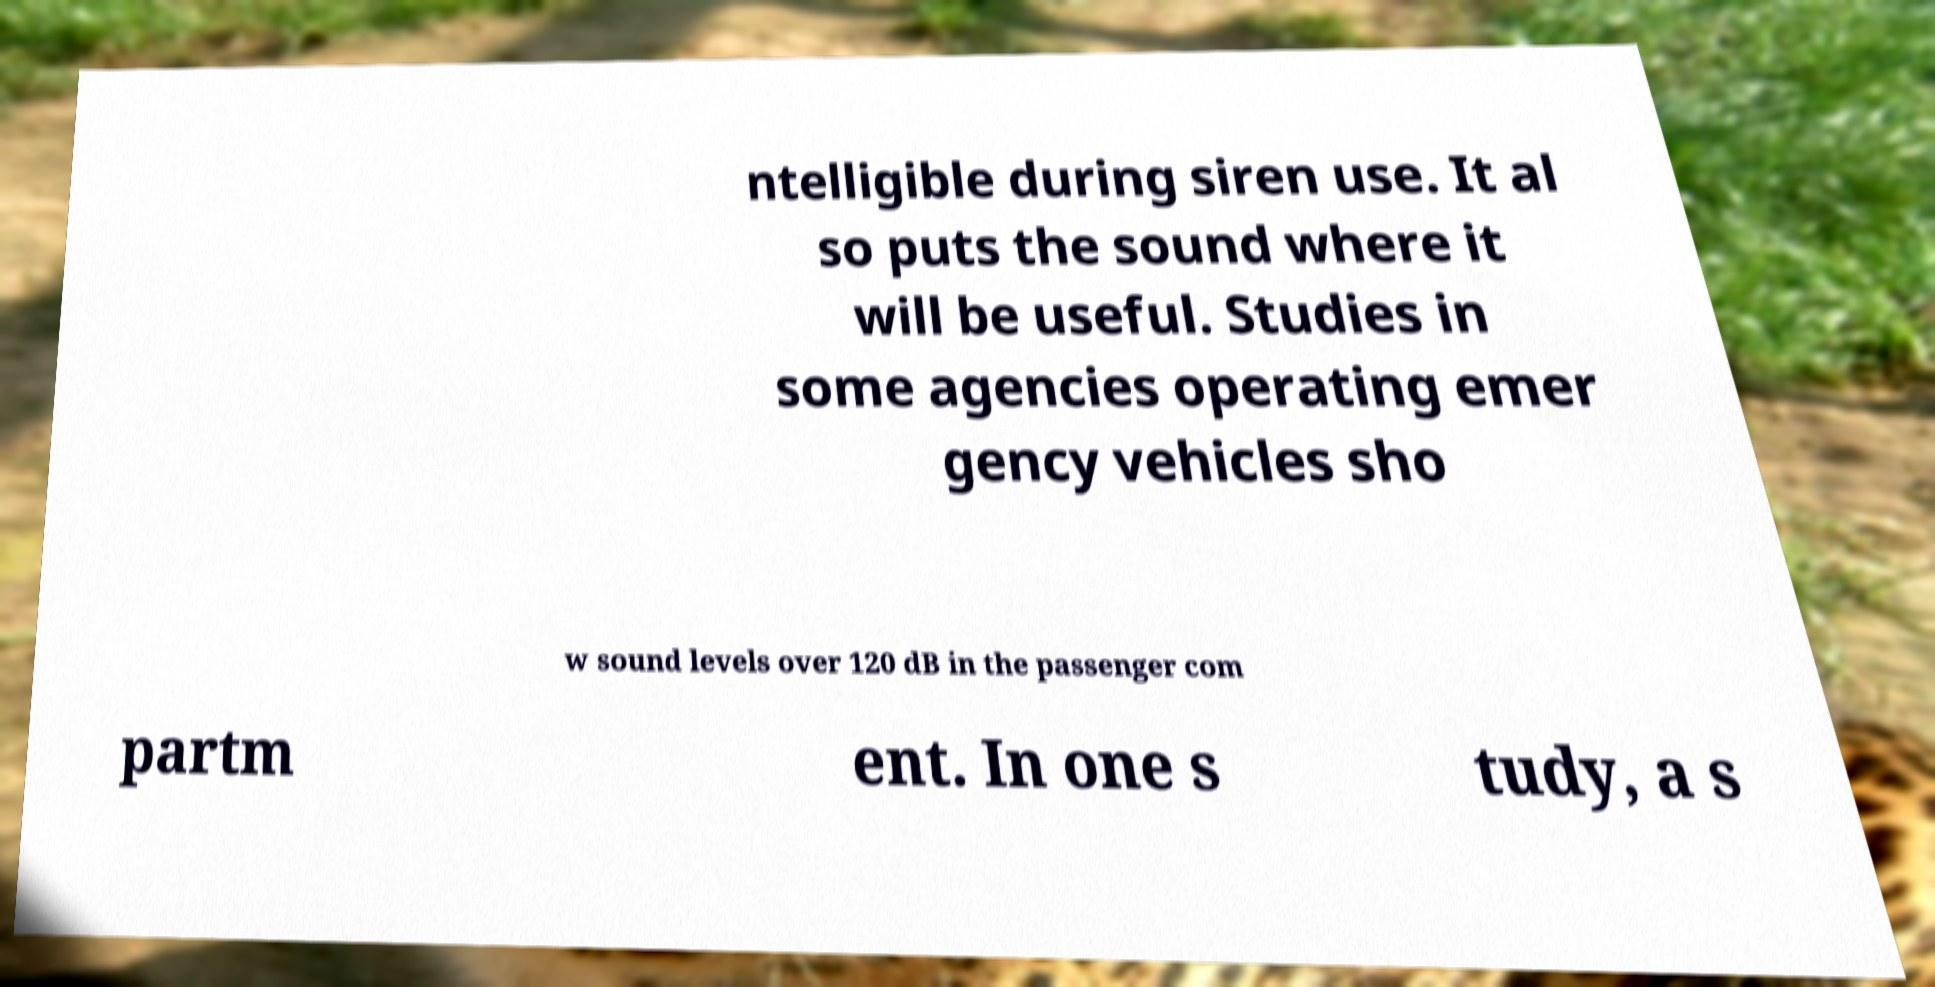Could you extract and type out the text from this image? ntelligible during siren use. It al so puts the sound where it will be useful. Studies in some agencies operating emer gency vehicles sho w sound levels over 120 dB in the passenger com partm ent. In one s tudy, a s 